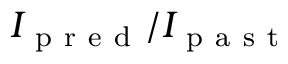Convert formula to latex. <formula><loc_0><loc_0><loc_500><loc_500>I _ { p r e d } / I _ { p a s t }</formula> 